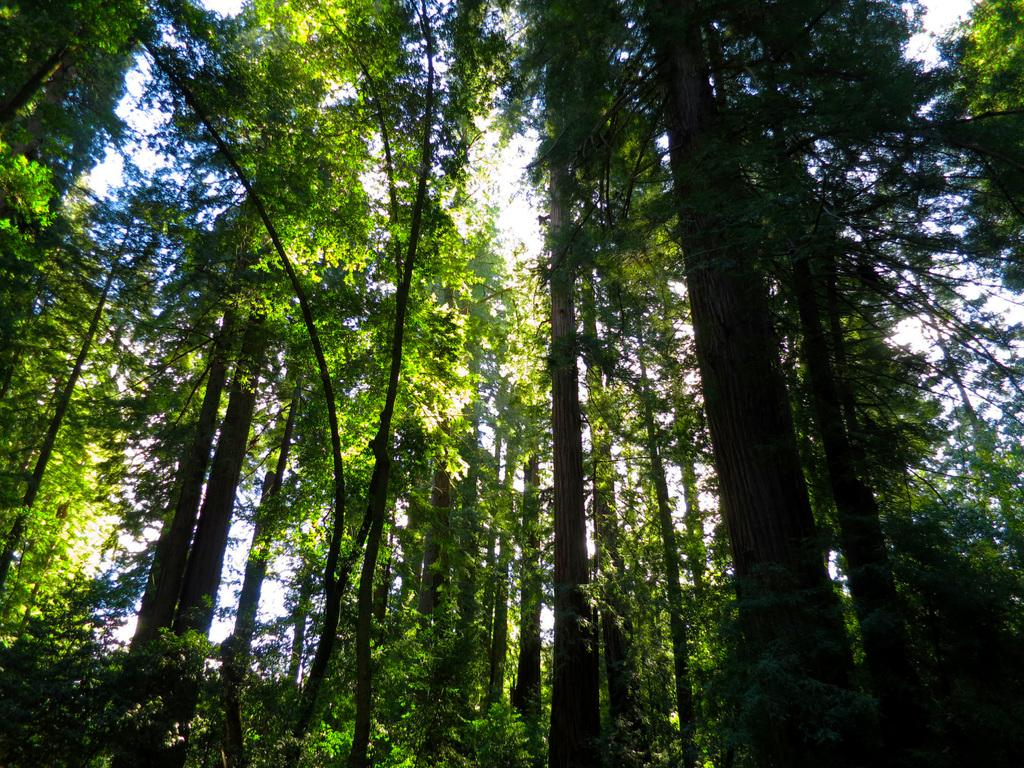What type of vegetation can be seen in the image? There are trees in the image. What is the color of the trees in the image? The trees are green in color. What else is visible in the image besides the trees? The sky is visible in the image. What is the color of the sky in the image? The sky is white in color. Can you tell me how many friends are playing in the band in the image? There is no band or friends present in the image; it features trees and a white sky. 